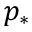<formula> <loc_0><loc_0><loc_500><loc_500>p _ { * }</formula> 